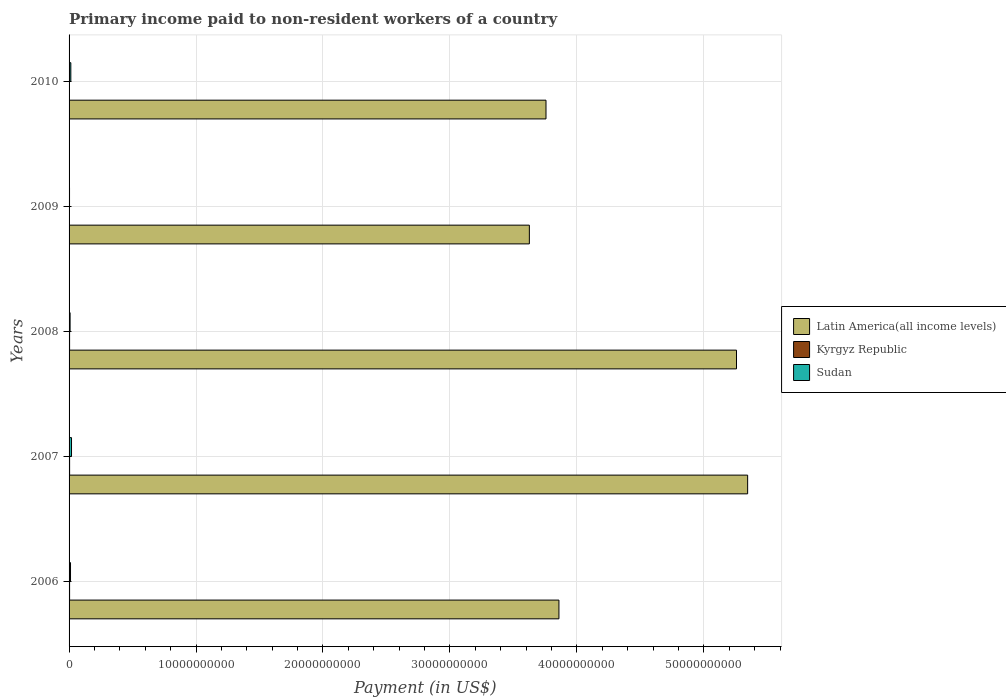How many different coloured bars are there?
Provide a short and direct response. 3. How many groups of bars are there?
Make the answer very short. 5. Are the number of bars per tick equal to the number of legend labels?
Offer a terse response. Yes. Are the number of bars on each tick of the Y-axis equal?
Ensure brevity in your answer.  Yes. What is the label of the 1st group of bars from the top?
Ensure brevity in your answer.  2010. In how many cases, is the number of bars for a given year not equal to the number of legend labels?
Your response must be concise. 0. What is the amount paid to workers in Sudan in 2010?
Make the answer very short. 1.39e+08. Across all years, what is the maximum amount paid to workers in Latin America(all income levels)?
Keep it short and to the point. 5.35e+1. Across all years, what is the minimum amount paid to workers in Kyrgyz Republic?
Give a very brief answer. 2.17e+07. In which year was the amount paid to workers in Kyrgyz Republic maximum?
Offer a terse response. 2007. In which year was the amount paid to workers in Sudan minimum?
Ensure brevity in your answer.  2009. What is the total amount paid to workers in Kyrgyz Republic in the graph?
Keep it short and to the point. 1.77e+08. What is the difference between the amount paid to workers in Sudan in 2007 and that in 2010?
Ensure brevity in your answer.  5.43e+07. What is the difference between the amount paid to workers in Sudan in 2006 and the amount paid to workers in Latin America(all income levels) in 2010?
Your response must be concise. -3.75e+1. What is the average amount paid to workers in Kyrgyz Republic per year?
Provide a short and direct response. 3.55e+07. In the year 2007, what is the difference between the amount paid to workers in Sudan and amount paid to workers in Kyrgyz Republic?
Offer a terse response. 1.50e+08. What is the ratio of the amount paid to workers in Kyrgyz Republic in 2007 to that in 2008?
Give a very brief answer. 1.02. Is the difference between the amount paid to workers in Sudan in 2006 and 2008 greater than the difference between the amount paid to workers in Kyrgyz Republic in 2006 and 2008?
Provide a succinct answer. Yes. What is the difference between the highest and the second highest amount paid to workers in Kyrgyz Republic?
Your answer should be very brief. 9.36e+05. What is the difference between the highest and the lowest amount paid to workers in Latin America(all income levels)?
Offer a terse response. 1.72e+1. In how many years, is the amount paid to workers in Sudan greater than the average amount paid to workers in Sudan taken over all years?
Offer a very short reply. 3. What does the 1st bar from the top in 2008 represents?
Give a very brief answer. Sudan. What does the 2nd bar from the bottom in 2010 represents?
Provide a short and direct response. Kyrgyz Republic. Is it the case that in every year, the sum of the amount paid to workers in Sudan and amount paid to workers in Kyrgyz Republic is greater than the amount paid to workers in Latin America(all income levels)?
Provide a short and direct response. No. Are all the bars in the graph horizontal?
Provide a short and direct response. Yes. Are the values on the major ticks of X-axis written in scientific E-notation?
Make the answer very short. No. Where does the legend appear in the graph?
Your answer should be compact. Center right. How many legend labels are there?
Offer a terse response. 3. What is the title of the graph?
Ensure brevity in your answer.  Primary income paid to non-resident workers of a country. Does "Brazil" appear as one of the legend labels in the graph?
Ensure brevity in your answer.  No. What is the label or title of the X-axis?
Make the answer very short. Payment (in US$). What is the label or title of the Y-axis?
Keep it short and to the point. Years. What is the Payment (in US$) of Latin America(all income levels) in 2006?
Give a very brief answer. 3.86e+1. What is the Payment (in US$) in Kyrgyz Republic in 2006?
Make the answer very short. 4.16e+07. What is the Payment (in US$) in Sudan in 2006?
Make the answer very short. 1.14e+08. What is the Payment (in US$) of Latin America(all income levels) in 2007?
Your response must be concise. 5.35e+1. What is the Payment (in US$) of Kyrgyz Republic in 2007?
Give a very brief answer. 4.26e+07. What is the Payment (in US$) in Sudan in 2007?
Offer a very short reply. 1.93e+08. What is the Payment (in US$) in Latin America(all income levels) in 2008?
Offer a very short reply. 5.26e+1. What is the Payment (in US$) in Kyrgyz Republic in 2008?
Your response must be concise. 4.17e+07. What is the Payment (in US$) of Sudan in 2008?
Ensure brevity in your answer.  8.05e+07. What is the Payment (in US$) in Latin America(all income levels) in 2009?
Ensure brevity in your answer.  3.63e+1. What is the Payment (in US$) of Kyrgyz Republic in 2009?
Provide a succinct answer. 2.17e+07. What is the Payment (in US$) in Sudan in 2009?
Provide a succinct answer. 3.67e+07. What is the Payment (in US$) of Latin America(all income levels) in 2010?
Provide a short and direct response. 3.76e+1. What is the Payment (in US$) in Kyrgyz Republic in 2010?
Your answer should be compact. 2.97e+07. What is the Payment (in US$) of Sudan in 2010?
Give a very brief answer. 1.39e+08. Across all years, what is the maximum Payment (in US$) in Latin America(all income levels)?
Provide a succinct answer. 5.35e+1. Across all years, what is the maximum Payment (in US$) of Kyrgyz Republic?
Your answer should be compact. 4.26e+07. Across all years, what is the maximum Payment (in US$) of Sudan?
Give a very brief answer. 1.93e+08. Across all years, what is the minimum Payment (in US$) in Latin America(all income levels)?
Your response must be concise. 3.63e+1. Across all years, what is the minimum Payment (in US$) of Kyrgyz Republic?
Give a very brief answer. 2.17e+07. Across all years, what is the minimum Payment (in US$) in Sudan?
Your response must be concise. 3.67e+07. What is the total Payment (in US$) in Latin America(all income levels) in the graph?
Your answer should be compact. 2.18e+11. What is the total Payment (in US$) of Kyrgyz Republic in the graph?
Your answer should be very brief. 1.77e+08. What is the total Payment (in US$) of Sudan in the graph?
Offer a very short reply. 5.63e+08. What is the difference between the Payment (in US$) in Latin America(all income levels) in 2006 and that in 2007?
Give a very brief answer. -1.49e+1. What is the difference between the Payment (in US$) in Kyrgyz Republic in 2006 and that in 2007?
Ensure brevity in your answer.  -1.00e+06. What is the difference between the Payment (in US$) of Sudan in 2006 and that in 2007?
Make the answer very short. -7.85e+07. What is the difference between the Payment (in US$) in Latin America(all income levels) in 2006 and that in 2008?
Provide a succinct answer. -1.40e+1. What is the difference between the Payment (in US$) in Kyrgyz Republic in 2006 and that in 2008?
Your answer should be compact. -6.58e+04. What is the difference between the Payment (in US$) in Sudan in 2006 and that in 2008?
Your answer should be very brief. 3.39e+07. What is the difference between the Payment (in US$) of Latin America(all income levels) in 2006 and that in 2009?
Make the answer very short. 2.33e+09. What is the difference between the Payment (in US$) in Kyrgyz Republic in 2006 and that in 2009?
Make the answer very short. 1.99e+07. What is the difference between the Payment (in US$) in Sudan in 2006 and that in 2009?
Offer a terse response. 7.76e+07. What is the difference between the Payment (in US$) in Latin America(all income levels) in 2006 and that in 2010?
Offer a very short reply. 1.02e+09. What is the difference between the Payment (in US$) in Kyrgyz Republic in 2006 and that in 2010?
Offer a very short reply. 1.20e+07. What is the difference between the Payment (in US$) in Sudan in 2006 and that in 2010?
Offer a terse response. -2.42e+07. What is the difference between the Payment (in US$) in Latin America(all income levels) in 2007 and that in 2008?
Provide a short and direct response. 8.77e+08. What is the difference between the Payment (in US$) in Kyrgyz Republic in 2007 and that in 2008?
Offer a very short reply. 9.36e+05. What is the difference between the Payment (in US$) of Sudan in 2007 and that in 2008?
Ensure brevity in your answer.  1.12e+08. What is the difference between the Payment (in US$) of Latin America(all income levels) in 2007 and that in 2009?
Your response must be concise. 1.72e+1. What is the difference between the Payment (in US$) in Kyrgyz Republic in 2007 and that in 2009?
Keep it short and to the point. 2.09e+07. What is the difference between the Payment (in US$) of Sudan in 2007 and that in 2009?
Your answer should be compact. 1.56e+08. What is the difference between the Payment (in US$) in Latin America(all income levels) in 2007 and that in 2010?
Provide a succinct answer. 1.59e+1. What is the difference between the Payment (in US$) of Kyrgyz Republic in 2007 and that in 2010?
Your answer should be very brief. 1.30e+07. What is the difference between the Payment (in US$) in Sudan in 2007 and that in 2010?
Make the answer very short. 5.43e+07. What is the difference between the Payment (in US$) of Latin America(all income levels) in 2008 and that in 2009?
Ensure brevity in your answer.  1.63e+1. What is the difference between the Payment (in US$) in Kyrgyz Republic in 2008 and that in 2009?
Ensure brevity in your answer.  2.00e+07. What is the difference between the Payment (in US$) in Sudan in 2008 and that in 2009?
Make the answer very short. 4.38e+07. What is the difference between the Payment (in US$) of Latin America(all income levels) in 2008 and that in 2010?
Ensure brevity in your answer.  1.50e+1. What is the difference between the Payment (in US$) of Kyrgyz Republic in 2008 and that in 2010?
Your answer should be very brief. 1.20e+07. What is the difference between the Payment (in US$) of Sudan in 2008 and that in 2010?
Offer a very short reply. -5.81e+07. What is the difference between the Payment (in US$) of Latin America(all income levels) in 2009 and that in 2010?
Offer a very short reply. -1.31e+09. What is the difference between the Payment (in US$) in Kyrgyz Republic in 2009 and that in 2010?
Your response must be concise. -7.97e+06. What is the difference between the Payment (in US$) of Sudan in 2009 and that in 2010?
Your response must be concise. -1.02e+08. What is the difference between the Payment (in US$) in Latin America(all income levels) in 2006 and the Payment (in US$) in Kyrgyz Republic in 2007?
Your response must be concise. 3.85e+1. What is the difference between the Payment (in US$) in Latin America(all income levels) in 2006 and the Payment (in US$) in Sudan in 2007?
Keep it short and to the point. 3.84e+1. What is the difference between the Payment (in US$) in Kyrgyz Republic in 2006 and the Payment (in US$) in Sudan in 2007?
Offer a very short reply. -1.51e+08. What is the difference between the Payment (in US$) of Latin America(all income levels) in 2006 and the Payment (in US$) of Kyrgyz Republic in 2008?
Provide a succinct answer. 3.85e+1. What is the difference between the Payment (in US$) of Latin America(all income levels) in 2006 and the Payment (in US$) of Sudan in 2008?
Your answer should be compact. 3.85e+1. What is the difference between the Payment (in US$) in Kyrgyz Republic in 2006 and the Payment (in US$) in Sudan in 2008?
Your response must be concise. -3.89e+07. What is the difference between the Payment (in US$) of Latin America(all income levels) in 2006 and the Payment (in US$) of Kyrgyz Republic in 2009?
Provide a short and direct response. 3.86e+1. What is the difference between the Payment (in US$) in Latin America(all income levels) in 2006 and the Payment (in US$) in Sudan in 2009?
Provide a succinct answer. 3.86e+1. What is the difference between the Payment (in US$) in Kyrgyz Republic in 2006 and the Payment (in US$) in Sudan in 2009?
Your answer should be compact. 4.88e+06. What is the difference between the Payment (in US$) of Latin America(all income levels) in 2006 and the Payment (in US$) of Kyrgyz Republic in 2010?
Offer a terse response. 3.86e+1. What is the difference between the Payment (in US$) in Latin America(all income levels) in 2006 and the Payment (in US$) in Sudan in 2010?
Ensure brevity in your answer.  3.84e+1. What is the difference between the Payment (in US$) of Kyrgyz Republic in 2006 and the Payment (in US$) of Sudan in 2010?
Your response must be concise. -9.70e+07. What is the difference between the Payment (in US$) of Latin America(all income levels) in 2007 and the Payment (in US$) of Kyrgyz Republic in 2008?
Your answer should be compact. 5.34e+1. What is the difference between the Payment (in US$) of Latin America(all income levels) in 2007 and the Payment (in US$) of Sudan in 2008?
Keep it short and to the point. 5.34e+1. What is the difference between the Payment (in US$) of Kyrgyz Republic in 2007 and the Payment (in US$) of Sudan in 2008?
Keep it short and to the point. -3.79e+07. What is the difference between the Payment (in US$) in Latin America(all income levels) in 2007 and the Payment (in US$) in Kyrgyz Republic in 2009?
Give a very brief answer. 5.34e+1. What is the difference between the Payment (in US$) of Latin America(all income levels) in 2007 and the Payment (in US$) of Sudan in 2009?
Make the answer very short. 5.34e+1. What is the difference between the Payment (in US$) of Kyrgyz Republic in 2007 and the Payment (in US$) of Sudan in 2009?
Your answer should be compact. 5.88e+06. What is the difference between the Payment (in US$) of Latin America(all income levels) in 2007 and the Payment (in US$) of Kyrgyz Republic in 2010?
Make the answer very short. 5.34e+1. What is the difference between the Payment (in US$) in Latin America(all income levels) in 2007 and the Payment (in US$) in Sudan in 2010?
Provide a short and direct response. 5.33e+1. What is the difference between the Payment (in US$) of Kyrgyz Republic in 2007 and the Payment (in US$) of Sudan in 2010?
Ensure brevity in your answer.  -9.60e+07. What is the difference between the Payment (in US$) in Latin America(all income levels) in 2008 and the Payment (in US$) in Kyrgyz Republic in 2009?
Your answer should be compact. 5.26e+1. What is the difference between the Payment (in US$) of Latin America(all income levels) in 2008 and the Payment (in US$) of Sudan in 2009?
Offer a terse response. 5.25e+1. What is the difference between the Payment (in US$) in Kyrgyz Republic in 2008 and the Payment (in US$) in Sudan in 2009?
Provide a succinct answer. 4.95e+06. What is the difference between the Payment (in US$) in Latin America(all income levels) in 2008 and the Payment (in US$) in Kyrgyz Republic in 2010?
Your answer should be compact. 5.25e+1. What is the difference between the Payment (in US$) in Latin America(all income levels) in 2008 and the Payment (in US$) in Sudan in 2010?
Your answer should be very brief. 5.24e+1. What is the difference between the Payment (in US$) in Kyrgyz Republic in 2008 and the Payment (in US$) in Sudan in 2010?
Your answer should be very brief. -9.69e+07. What is the difference between the Payment (in US$) in Latin America(all income levels) in 2009 and the Payment (in US$) in Kyrgyz Republic in 2010?
Make the answer very short. 3.62e+1. What is the difference between the Payment (in US$) of Latin America(all income levels) in 2009 and the Payment (in US$) of Sudan in 2010?
Ensure brevity in your answer.  3.61e+1. What is the difference between the Payment (in US$) of Kyrgyz Republic in 2009 and the Payment (in US$) of Sudan in 2010?
Your response must be concise. -1.17e+08. What is the average Payment (in US$) in Latin America(all income levels) per year?
Offer a very short reply. 4.37e+1. What is the average Payment (in US$) of Kyrgyz Republic per year?
Your answer should be compact. 3.55e+07. What is the average Payment (in US$) of Sudan per year?
Give a very brief answer. 1.13e+08. In the year 2006, what is the difference between the Payment (in US$) of Latin America(all income levels) and Payment (in US$) of Kyrgyz Republic?
Give a very brief answer. 3.85e+1. In the year 2006, what is the difference between the Payment (in US$) in Latin America(all income levels) and Payment (in US$) in Sudan?
Your answer should be very brief. 3.85e+1. In the year 2006, what is the difference between the Payment (in US$) of Kyrgyz Republic and Payment (in US$) of Sudan?
Keep it short and to the point. -7.28e+07. In the year 2007, what is the difference between the Payment (in US$) in Latin America(all income levels) and Payment (in US$) in Kyrgyz Republic?
Offer a very short reply. 5.34e+1. In the year 2007, what is the difference between the Payment (in US$) of Latin America(all income levels) and Payment (in US$) of Sudan?
Offer a terse response. 5.33e+1. In the year 2007, what is the difference between the Payment (in US$) in Kyrgyz Republic and Payment (in US$) in Sudan?
Your answer should be very brief. -1.50e+08. In the year 2008, what is the difference between the Payment (in US$) in Latin America(all income levels) and Payment (in US$) in Kyrgyz Republic?
Your response must be concise. 5.25e+1. In the year 2008, what is the difference between the Payment (in US$) in Latin America(all income levels) and Payment (in US$) in Sudan?
Your response must be concise. 5.25e+1. In the year 2008, what is the difference between the Payment (in US$) in Kyrgyz Republic and Payment (in US$) in Sudan?
Your answer should be compact. -3.88e+07. In the year 2009, what is the difference between the Payment (in US$) of Latin America(all income levels) and Payment (in US$) of Kyrgyz Republic?
Your answer should be compact. 3.62e+1. In the year 2009, what is the difference between the Payment (in US$) of Latin America(all income levels) and Payment (in US$) of Sudan?
Provide a short and direct response. 3.62e+1. In the year 2009, what is the difference between the Payment (in US$) of Kyrgyz Republic and Payment (in US$) of Sudan?
Keep it short and to the point. -1.51e+07. In the year 2010, what is the difference between the Payment (in US$) of Latin America(all income levels) and Payment (in US$) of Kyrgyz Republic?
Offer a very short reply. 3.75e+1. In the year 2010, what is the difference between the Payment (in US$) in Latin America(all income levels) and Payment (in US$) in Sudan?
Offer a terse response. 3.74e+1. In the year 2010, what is the difference between the Payment (in US$) in Kyrgyz Republic and Payment (in US$) in Sudan?
Make the answer very short. -1.09e+08. What is the ratio of the Payment (in US$) of Latin America(all income levels) in 2006 to that in 2007?
Ensure brevity in your answer.  0.72. What is the ratio of the Payment (in US$) in Kyrgyz Republic in 2006 to that in 2007?
Offer a very short reply. 0.98. What is the ratio of the Payment (in US$) of Sudan in 2006 to that in 2007?
Your answer should be very brief. 0.59. What is the ratio of the Payment (in US$) of Latin America(all income levels) in 2006 to that in 2008?
Ensure brevity in your answer.  0.73. What is the ratio of the Payment (in US$) of Sudan in 2006 to that in 2008?
Your answer should be very brief. 1.42. What is the ratio of the Payment (in US$) in Latin America(all income levels) in 2006 to that in 2009?
Provide a short and direct response. 1.06. What is the ratio of the Payment (in US$) in Kyrgyz Republic in 2006 to that in 2009?
Ensure brevity in your answer.  1.92. What is the ratio of the Payment (in US$) in Sudan in 2006 to that in 2009?
Provide a short and direct response. 3.11. What is the ratio of the Payment (in US$) in Latin America(all income levels) in 2006 to that in 2010?
Keep it short and to the point. 1.03. What is the ratio of the Payment (in US$) of Kyrgyz Republic in 2006 to that in 2010?
Ensure brevity in your answer.  1.4. What is the ratio of the Payment (in US$) in Sudan in 2006 to that in 2010?
Offer a very short reply. 0.83. What is the ratio of the Payment (in US$) of Latin America(all income levels) in 2007 to that in 2008?
Offer a terse response. 1.02. What is the ratio of the Payment (in US$) in Kyrgyz Republic in 2007 to that in 2008?
Your answer should be compact. 1.02. What is the ratio of the Payment (in US$) of Sudan in 2007 to that in 2008?
Provide a short and direct response. 2.4. What is the ratio of the Payment (in US$) in Latin America(all income levels) in 2007 to that in 2009?
Keep it short and to the point. 1.47. What is the ratio of the Payment (in US$) of Kyrgyz Republic in 2007 to that in 2009?
Make the answer very short. 1.97. What is the ratio of the Payment (in US$) in Sudan in 2007 to that in 2009?
Make the answer very short. 5.25. What is the ratio of the Payment (in US$) of Latin America(all income levels) in 2007 to that in 2010?
Your answer should be compact. 1.42. What is the ratio of the Payment (in US$) in Kyrgyz Republic in 2007 to that in 2010?
Make the answer very short. 1.44. What is the ratio of the Payment (in US$) in Sudan in 2007 to that in 2010?
Provide a short and direct response. 1.39. What is the ratio of the Payment (in US$) in Latin America(all income levels) in 2008 to that in 2009?
Keep it short and to the point. 1.45. What is the ratio of the Payment (in US$) of Kyrgyz Republic in 2008 to that in 2009?
Your response must be concise. 1.92. What is the ratio of the Payment (in US$) of Sudan in 2008 to that in 2009?
Your answer should be very brief. 2.19. What is the ratio of the Payment (in US$) of Latin America(all income levels) in 2008 to that in 2010?
Your answer should be very brief. 1.4. What is the ratio of the Payment (in US$) in Kyrgyz Republic in 2008 to that in 2010?
Make the answer very short. 1.41. What is the ratio of the Payment (in US$) in Sudan in 2008 to that in 2010?
Offer a very short reply. 0.58. What is the ratio of the Payment (in US$) in Latin America(all income levels) in 2009 to that in 2010?
Give a very brief answer. 0.97. What is the ratio of the Payment (in US$) in Kyrgyz Republic in 2009 to that in 2010?
Give a very brief answer. 0.73. What is the ratio of the Payment (in US$) in Sudan in 2009 to that in 2010?
Provide a succinct answer. 0.27. What is the difference between the highest and the second highest Payment (in US$) in Latin America(all income levels)?
Your answer should be compact. 8.77e+08. What is the difference between the highest and the second highest Payment (in US$) in Kyrgyz Republic?
Keep it short and to the point. 9.36e+05. What is the difference between the highest and the second highest Payment (in US$) of Sudan?
Provide a succinct answer. 5.43e+07. What is the difference between the highest and the lowest Payment (in US$) in Latin America(all income levels)?
Your response must be concise. 1.72e+1. What is the difference between the highest and the lowest Payment (in US$) in Kyrgyz Republic?
Provide a short and direct response. 2.09e+07. What is the difference between the highest and the lowest Payment (in US$) in Sudan?
Ensure brevity in your answer.  1.56e+08. 